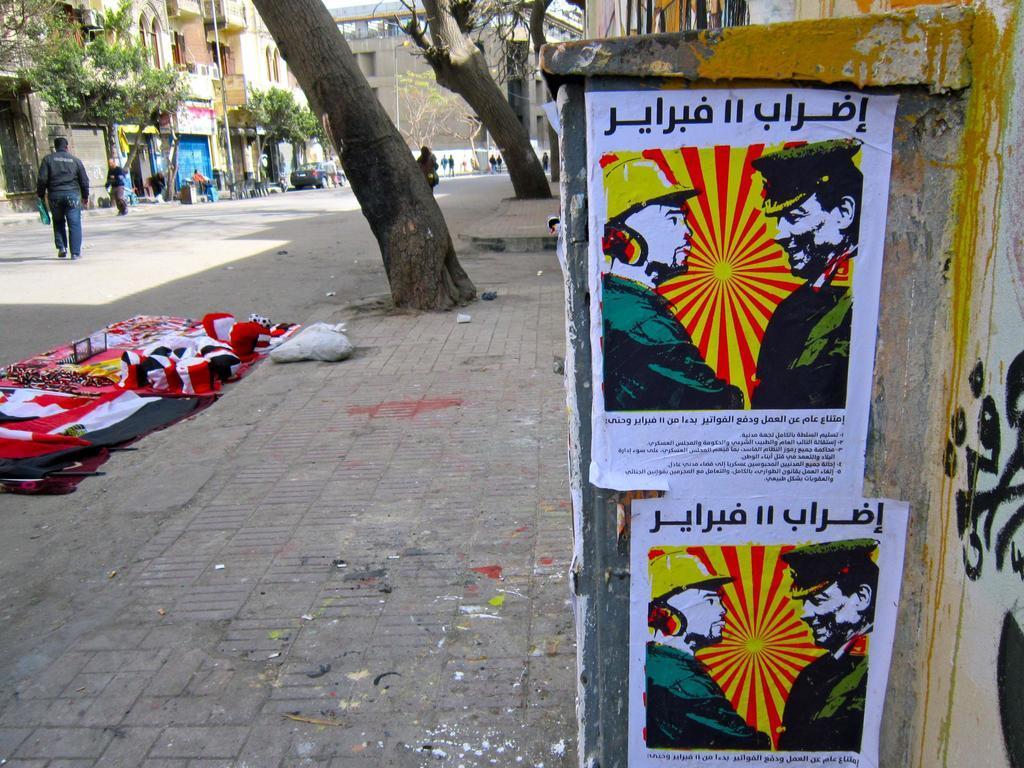Could you give a brief overview of what you see in this image? In this image there are people walking on the road. There is a car. There are clothes on the road. On the right side of the image there are posters attached to the wall. In the background of the image there are poles, trees, buildings. 